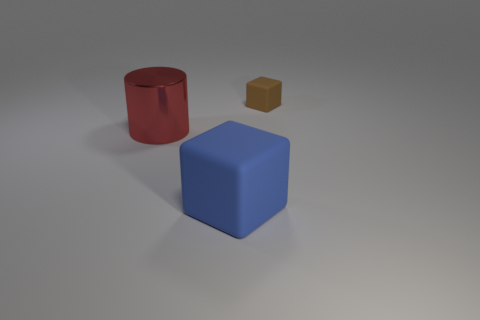There is a matte object that is in front of the large red thing; is it the same size as the object behind the large shiny cylinder?
Your answer should be compact. No. Are there fewer big gray cylinders than shiny things?
Make the answer very short. Yes. There is a blue matte cube; what number of rubber cubes are behind it?
Give a very brief answer. 1. What material is the red cylinder?
Offer a very short reply. Metal. Does the large metal cylinder have the same color as the large matte object?
Keep it short and to the point. No. Are there fewer cylinders that are in front of the cylinder than big green metal cubes?
Make the answer very short. No. There is a big object that is right of the metallic cylinder; what color is it?
Ensure brevity in your answer.  Blue. The big metallic thing is what shape?
Your answer should be compact. Cylinder. There is a thing that is right of the cube that is left of the brown block; are there any blue cubes right of it?
Ensure brevity in your answer.  No. There is a matte block in front of the large thing behind the rubber object that is in front of the big red cylinder; what is its color?
Offer a very short reply. Blue. 